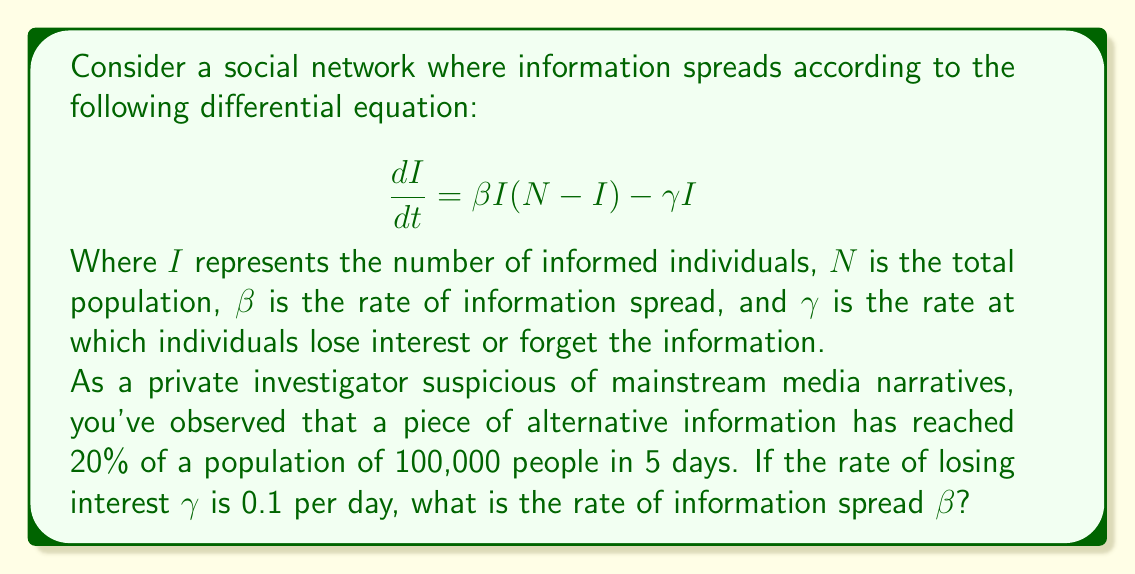Can you answer this question? Let's approach this step-by-step:

1) We're given that $N = 100,000$ and after 5 days, $I = 20,000$ (20% of 100,000).

2) At equilibrium, $\frac{dI}{dt} = 0$. So we can set up the equation:

   $$0 = \beta I(N-I) - \gamma I$$

3) Substituting the known values:

   $$0 = \beta (20,000)(100,000-20,000) - 0.1(20,000)$$

4) Simplify:

   $$0 = \beta (20,000)(80,000) - 2,000$$
   $$0 = 1,600,000,000\beta - 2,000$$

5) Solve for $\beta$:

   $$1,600,000,000\beta = 2,000$$
   $$\beta = \frac{2,000}{1,600,000,000} = \frac{1}{800,000} = 1.25 \times 10^{-6}$$

6) Therefore, the rate of information spread $\beta$ is approximately $1.25 \times 10^{-6}$ per person per day.

This low value of $\beta$ suggests that the alternative information is spreading slowly through the network, possibly due to resistance from mainstream narratives or limited initial exposure.
Answer: $\beta \approx 1.25 \times 10^{-6}$ per person per day 